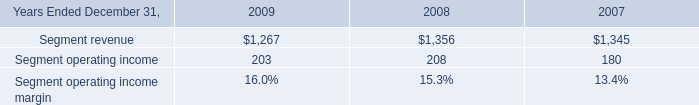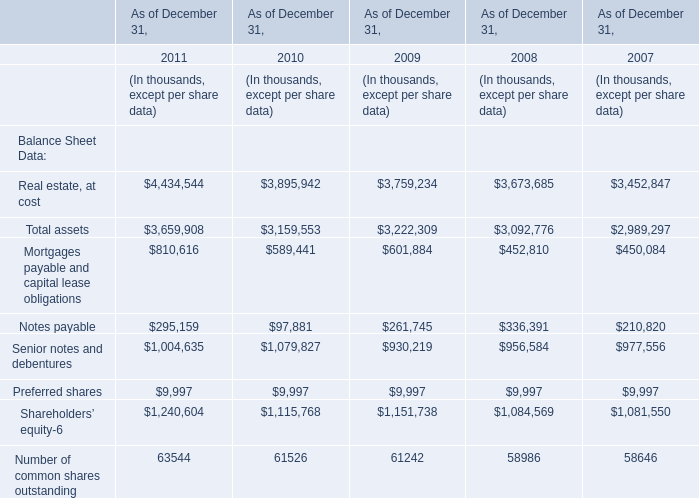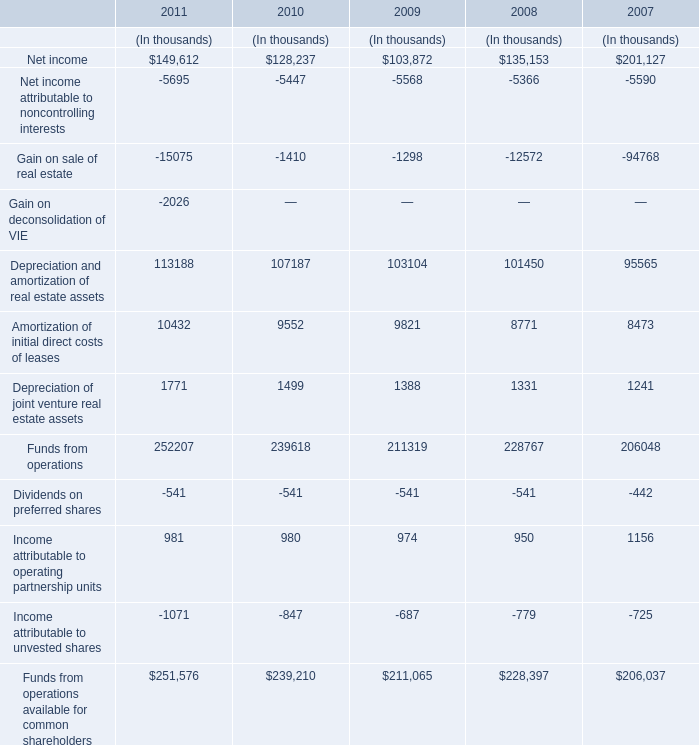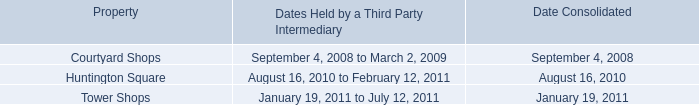What will Total assets be like in 2012 if it develops with the same increasing rate as current? (in thousand) 
Computations: (3659908 * (1 + ((3659908 - 3159553) / 3159553)))
Answer: 4239500.5143. 